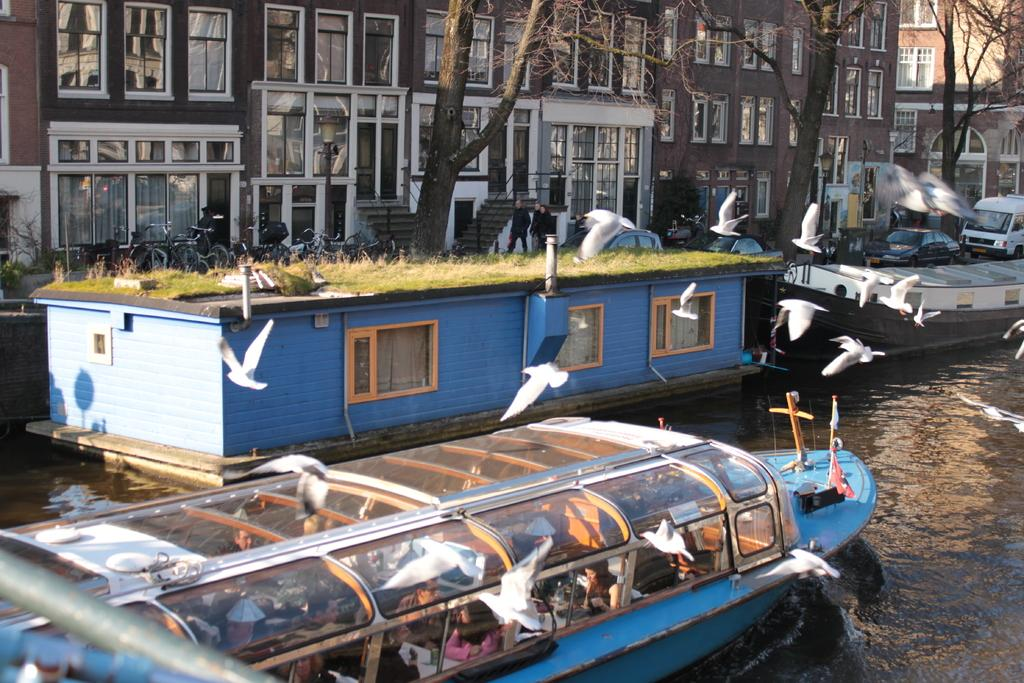What type of vegetation can be seen in the image? There is grass in the image. What are the boats in the image like? The boats in the image are white in color. What is the water in the image used for? The water in the image is likely used for boating or other water activities. What type of structures can be seen in the image? There are buildings in the image. What other natural elements can be seen in the image? There are trees in the image. How many types of boats are visible in the image? There are boats in the image, and they are white in color. Where is the market located in the image? There is no market present in the image. What color is the pencil used to draw the trees in the image? There is no pencil or drawing present in the image; it is a photograph of real trees. 